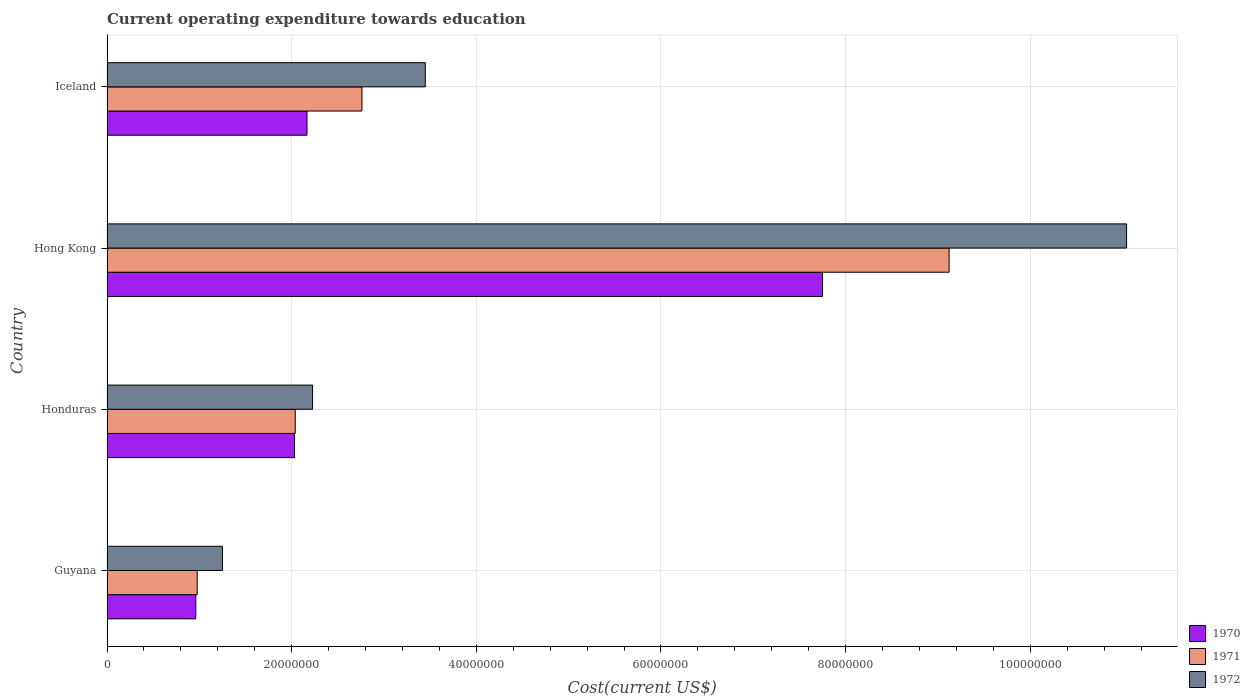What is the label of the 3rd group of bars from the top?
Keep it short and to the point. Honduras. In how many cases, is the number of bars for a given country not equal to the number of legend labels?
Provide a short and direct response. 0. What is the expenditure towards education in 1970 in Iceland?
Offer a very short reply. 2.17e+07. Across all countries, what is the maximum expenditure towards education in 1972?
Make the answer very short. 1.10e+08. Across all countries, what is the minimum expenditure towards education in 1971?
Your response must be concise. 9.77e+06. In which country was the expenditure towards education in 1971 maximum?
Provide a short and direct response. Hong Kong. In which country was the expenditure towards education in 1970 minimum?
Provide a succinct answer. Guyana. What is the total expenditure towards education in 1971 in the graph?
Your answer should be compact. 1.49e+08. What is the difference between the expenditure towards education in 1970 in Guyana and that in Iceland?
Your response must be concise. -1.20e+07. What is the difference between the expenditure towards education in 1972 in Guyana and the expenditure towards education in 1971 in Honduras?
Your answer should be very brief. -7.88e+06. What is the average expenditure towards education in 1971 per country?
Make the answer very short. 3.72e+07. What is the difference between the expenditure towards education in 1971 and expenditure towards education in 1970 in Hong Kong?
Ensure brevity in your answer.  1.37e+07. What is the ratio of the expenditure towards education in 1970 in Guyana to that in Honduras?
Your answer should be very brief. 0.47. What is the difference between the highest and the second highest expenditure towards education in 1970?
Give a very brief answer. 5.58e+07. What is the difference between the highest and the lowest expenditure towards education in 1970?
Your answer should be compact. 6.79e+07. Is the sum of the expenditure towards education in 1971 in Honduras and Hong Kong greater than the maximum expenditure towards education in 1972 across all countries?
Make the answer very short. Yes. What does the 1st bar from the top in Iceland represents?
Your response must be concise. 1972. Is it the case that in every country, the sum of the expenditure towards education in 1972 and expenditure towards education in 1970 is greater than the expenditure towards education in 1971?
Offer a terse response. Yes. What is the difference between two consecutive major ticks on the X-axis?
Ensure brevity in your answer.  2.00e+07. Does the graph contain grids?
Keep it short and to the point. Yes. How are the legend labels stacked?
Ensure brevity in your answer.  Vertical. What is the title of the graph?
Provide a succinct answer. Current operating expenditure towards education. What is the label or title of the X-axis?
Offer a very short reply. Cost(current US$). What is the Cost(current US$) of 1970 in Guyana?
Ensure brevity in your answer.  9.62e+06. What is the Cost(current US$) of 1971 in Guyana?
Your response must be concise. 9.77e+06. What is the Cost(current US$) of 1972 in Guyana?
Offer a terse response. 1.25e+07. What is the Cost(current US$) of 1970 in Honduras?
Offer a very short reply. 2.03e+07. What is the Cost(current US$) of 1971 in Honduras?
Make the answer very short. 2.04e+07. What is the Cost(current US$) in 1972 in Honduras?
Make the answer very short. 2.23e+07. What is the Cost(current US$) of 1970 in Hong Kong?
Provide a succinct answer. 7.75e+07. What is the Cost(current US$) in 1971 in Hong Kong?
Provide a succinct answer. 9.12e+07. What is the Cost(current US$) of 1972 in Hong Kong?
Make the answer very short. 1.10e+08. What is the Cost(current US$) of 1970 in Iceland?
Your answer should be compact. 2.17e+07. What is the Cost(current US$) of 1971 in Iceland?
Your answer should be very brief. 2.76e+07. What is the Cost(current US$) in 1972 in Iceland?
Your answer should be compact. 3.45e+07. Across all countries, what is the maximum Cost(current US$) of 1970?
Offer a very short reply. 7.75e+07. Across all countries, what is the maximum Cost(current US$) in 1971?
Keep it short and to the point. 9.12e+07. Across all countries, what is the maximum Cost(current US$) of 1972?
Your answer should be compact. 1.10e+08. Across all countries, what is the minimum Cost(current US$) in 1970?
Keep it short and to the point. 9.62e+06. Across all countries, what is the minimum Cost(current US$) in 1971?
Your answer should be very brief. 9.77e+06. Across all countries, what is the minimum Cost(current US$) of 1972?
Offer a very short reply. 1.25e+07. What is the total Cost(current US$) in 1970 in the graph?
Provide a succinct answer. 1.29e+08. What is the total Cost(current US$) of 1971 in the graph?
Provide a short and direct response. 1.49e+08. What is the total Cost(current US$) of 1972 in the graph?
Provide a short and direct response. 1.80e+08. What is the difference between the Cost(current US$) of 1970 in Guyana and that in Honduras?
Give a very brief answer. -1.07e+07. What is the difference between the Cost(current US$) of 1971 in Guyana and that in Honduras?
Make the answer very short. -1.06e+07. What is the difference between the Cost(current US$) in 1972 in Guyana and that in Honduras?
Offer a very short reply. -9.76e+06. What is the difference between the Cost(current US$) of 1970 in Guyana and that in Hong Kong?
Provide a succinct answer. -6.79e+07. What is the difference between the Cost(current US$) in 1971 in Guyana and that in Hong Kong?
Give a very brief answer. -8.14e+07. What is the difference between the Cost(current US$) of 1972 in Guyana and that in Hong Kong?
Your answer should be very brief. -9.79e+07. What is the difference between the Cost(current US$) of 1970 in Guyana and that in Iceland?
Provide a succinct answer. -1.20e+07. What is the difference between the Cost(current US$) in 1971 in Guyana and that in Iceland?
Your answer should be very brief. -1.78e+07. What is the difference between the Cost(current US$) in 1972 in Guyana and that in Iceland?
Ensure brevity in your answer.  -2.20e+07. What is the difference between the Cost(current US$) in 1970 in Honduras and that in Hong Kong?
Give a very brief answer. -5.72e+07. What is the difference between the Cost(current US$) in 1971 in Honduras and that in Hong Kong?
Give a very brief answer. -7.08e+07. What is the difference between the Cost(current US$) in 1972 in Honduras and that in Hong Kong?
Your response must be concise. -8.82e+07. What is the difference between the Cost(current US$) of 1970 in Honduras and that in Iceland?
Offer a terse response. -1.35e+06. What is the difference between the Cost(current US$) in 1971 in Honduras and that in Iceland?
Provide a short and direct response. -7.23e+06. What is the difference between the Cost(current US$) in 1972 in Honduras and that in Iceland?
Ensure brevity in your answer.  -1.22e+07. What is the difference between the Cost(current US$) of 1970 in Hong Kong and that in Iceland?
Your answer should be very brief. 5.58e+07. What is the difference between the Cost(current US$) in 1971 in Hong Kong and that in Iceland?
Keep it short and to the point. 6.36e+07. What is the difference between the Cost(current US$) in 1972 in Hong Kong and that in Iceland?
Your answer should be compact. 7.60e+07. What is the difference between the Cost(current US$) in 1970 in Guyana and the Cost(current US$) in 1971 in Honduras?
Your answer should be compact. -1.08e+07. What is the difference between the Cost(current US$) in 1970 in Guyana and the Cost(current US$) in 1972 in Honduras?
Ensure brevity in your answer.  -1.27e+07. What is the difference between the Cost(current US$) in 1971 in Guyana and the Cost(current US$) in 1972 in Honduras?
Your answer should be very brief. -1.25e+07. What is the difference between the Cost(current US$) in 1970 in Guyana and the Cost(current US$) in 1971 in Hong Kong?
Give a very brief answer. -8.16e+07. What is the difference between the Cost(current US$) of 1970 in Guyana and the Cost(current US$) of 1972 in Hong Kong?
Provide a succinct answer. -1.01e+08. What is the difference between the Cost(current US$) of 1971 in Guyana and the Cost(current US$) of 1972 in Hong Kong?
Give a very brief answer. -1.01e+08. What is the difference between the Cost(current US$) in 1970 in Guyana and the Cost(current US$) in 1971 in Iceland?
Make the answer very short. -1.80e+07. What is the difference between the Cost(current US$) of 1970 in Guyana and the Cost(current US$) of 1972 in Iceland?
Your answer should be very brief. -2.49e+07. What is the difference between the Cost(current US$) in 1971 in Guyana and the Cost(current US$) in 1972 in Iceland?
Your answer should be very brief. -2.47e+07. What is the difference between the Cost(current US$) of 1970 in Honduras and the Cost(current US$) of 1971 in Hong Kong?
Make the answer very short. -7.09e+07. What is the difference between the Cost(current US$) in 1970 in Honduras and the Cost(current US$) in 1972 in Hong Kong?
Make the answer very short. -9.01e+07. What is the difference between the Cost(current US$) in 1971 in Honduras and the Cost(current US$) in 1972 in Hong Kong?
Ensure brevity in your answer.  -9.00e+07. What is the difference between the Cost(current US$) of 1970 in Honduras and the Cost(current US$) of 1971 in Iceland?
Ensure brevity in your answer.  -7.30e+06. What is the difference between the Cost(current US$) in 1970 in Honduras and the Cost(current US$) in 1972 in Iceland?
Ensure brevity in your answer.  -1.42e+07. What is the difference between the Cost(current US$) of 1971 in Honduras and the Cost(current US$) of 1972 in Iceland?
Offer a very short reply. -1.41e+07. What is the difference between the Cost(current US$) in 1970 in Hong Kong and the Cost(current US$) in 1971 in Iceland?
Give a very brief answer. 4.99e+07. What is the difference between the Cost(current US$) in 1970 in Hong Kong and the Cost(current US$) in 1972 in Iceland?
Provide a short and direct response. 4.30e+07. What is the difference between the Cost(current US$) in 1971 in Hong Kong and the Cost(current US$) in 1972 in Iceland?
Your answer should be very brief. 5.67e+07. What is the average Cost(current US$) of 1970 per country?
Provide a short and direct response. 3.23e+07. What is the average Cost(current US$) of 1971 per country?
Make the answer very short. 3.72e+07. What is the average Cost(current US$) in 1972 per country?
Keep it short and to the point. 4.49e+07. What is the difference between the Cost(current US$) of 1970 and Cost(current US$) of 1971 in Guyana?
Offer a terse response. -1.54e+05. What is the difference between the Cost(current US$) of 1970 and Cost(current US$) of 1972 in Guyana?
Your answer should be very brief. -2.89e+06. What is the difference between the Cost(current US$) in 1971 and Cost(current US$) in 1972 in Guyana?
Your response must be concise. -2.73e+06. What is the difference between the Cost(current US$) in 1970 and Cost(current US$) in 1971 in Honduras?
Provide a succinct answer. -7.60e+04. What is the difference between the Cost(current US$) in 1970 and Cost(current US$) in 1972 in Honduras?
Keep it short and to the point. -1.96e+06. What is the difference between the Cost(current US$) of 1971 and Cost(current US$) of 1972 in Honduras?
Give a very brief answer. -1.88e+06. What is the difference between the Cost(current US$) of 1970 and Cost(current US$) of 1971 in Hong Kong?
Your answer should be compact. -1.37e+07. What is the difference between the Cost(current US$) of 1970 and Cost(current US$) of 1972 in Hong Kong?
Give a very brief answer. -3.29e+07. What is the difference between the Cost(current US$) of 1971 and Cost(current US$) of 1972 in Hong Kong?
Give a very brief answer. -1.92e+07. What is the difference between the Cost(current US$) of 1970 and Cost(current US$) of 1971 in Iceland?
Provide a succinct answer. -5.95e+06. What is the difference between the Cost(current US$) in 1970 and Cost(current US$) in 1972 in Iceland?
Ensure brevity in your answer.  -1.28e+07. What is the difference between the Cost(current US$) in 1971 and Cost(current US$) in 1972 in Iceland?
Your answer should be very brief. -6.86e+06. What is the ratio of the Cost(current US$) of 1970 in Guyana to that in Honduras?
Provide a short and direct response. 0.47. What is the ratio of the Cost(current US$) in 1971 in Guyana to that in Honduras?
Make the answer very short. 0.48. What is the ratio of the Cost(current US$) in 1972 in Guyana to that in Honduras?
Your answer should be very brief. 0.56. What is the ratio of the Cost(current US$) of 1970 in Guyana to that in Hong Kong?
Your response must be concise. 0.12. What is the ratio of the Cost(current US$) in 1971 in Guyana to that in Hong Kong?
Make the answer very short. 0.11. What is the ratio of the Cost(current US$) in 1972 in Guyana to that in Hong Kong?
Ensure brevity in your answer.  0.11. What is the ratio of the Cost(current US$) in 1970 in Guyana to that in Iceland?
Your answer should be compact. 0.44. What is the ratio of the Cost(current US$) in 1971 in Guyana to that in Iceland?
Make the answer very short. 0.35. What is the ratio of the Cost(current US$) in 1972 in Guyana to that in Iceland?
Keep it short and to the point. 0.36. What is the ratio of the Cost(current US$) in 1970 in Honduras to that in Hong Kong?
Give a very brief answer. 0.26. What is the ratio of the Cost(current US$) of 1971 in Honduras to that in Hong Kong?
Give a very brief answer. 0.22. What is the ratio of the Cost(current US$) of 1972 in Honduras to that in Hong Kong?
Ensure brevity in your answer.  0.2. What is the ratio of the Cost(current US$) in 1970 in Honduras to that in Iceland?
Offer a terse response. 0.94. What is the ratio of the Cost(current US$) of 1971 in Honduras to that in Iceland?
Ensure brevity in your answer.  0.74. What is the ratio of the Cost(current US$) of 1972 in Honduras to that in Iceland?
Keep it short and to the point. 0.65. What is the ratio of the Cost(current US$) of 1970 in Hong Kong to that in Iceland?
Keep it short and to the point. 3.58. What is the ratio of the Cost(current US$) in 1971 in Hong Kong to that in Iceland?
Your answer should be compact. 3.3. What is the ratio of the Cost(current US$) of 1972 in Hong Kong to that in Iceland?
Your answer should be very brief. 3.2. What is the difference between the highest and the second highest Cost(current US$) of 1970?
Your answer should be compact. 5.58e+07. What is the difference between the highest and the second highest Cost(current US$) in 1971?
Keep it short and to the point. 6.36e+07. What is the difference between the highest and the second highest Cost(current US$) of 1972?
Your answer should be very brief. 7.60e+07. What is the difference between the highest and the lowest Cost(current US$) in 1970?
Provide a succinct answer. 6.79e+07. What is the difference between the highest and the lowest Cost(current US$) in 1971?
Your answer should be very brief. 8.14e+07. What is the difference between the highest and the lowest Cost(current US$) in 1972?
Ensure brevity in your answer.  9.79e+07. 